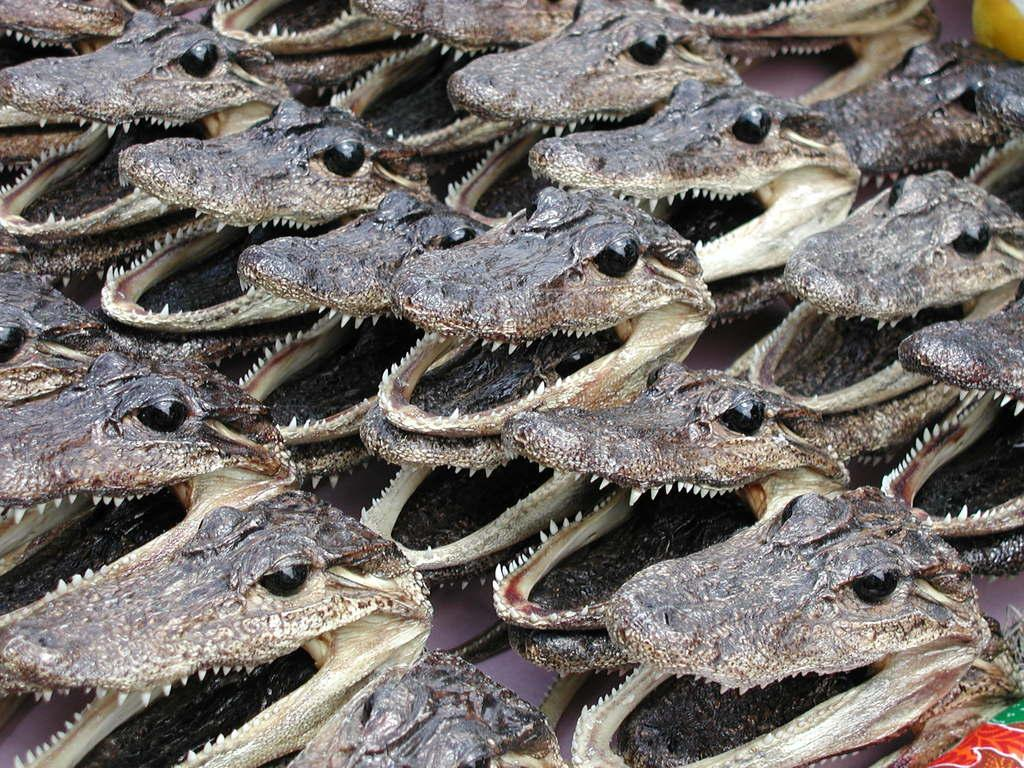What type of objects are present in the image? There are skulls of animals in the image. Can you describe the appearance of the skulls? The skulls are likely to have eye sockets, a jawbone, and other recognizable features of animal skulls. What might be the purpose of displaying these skulls? The purpose could be for educational, artistic, or decorative purposes. Where can you find the zoo in the image? There is no zoo present in the image; it only contains skulls of animals. How does the discussion between the animals take place in the image? There is no discussion between animals in the image, as it only contains their skulls. 